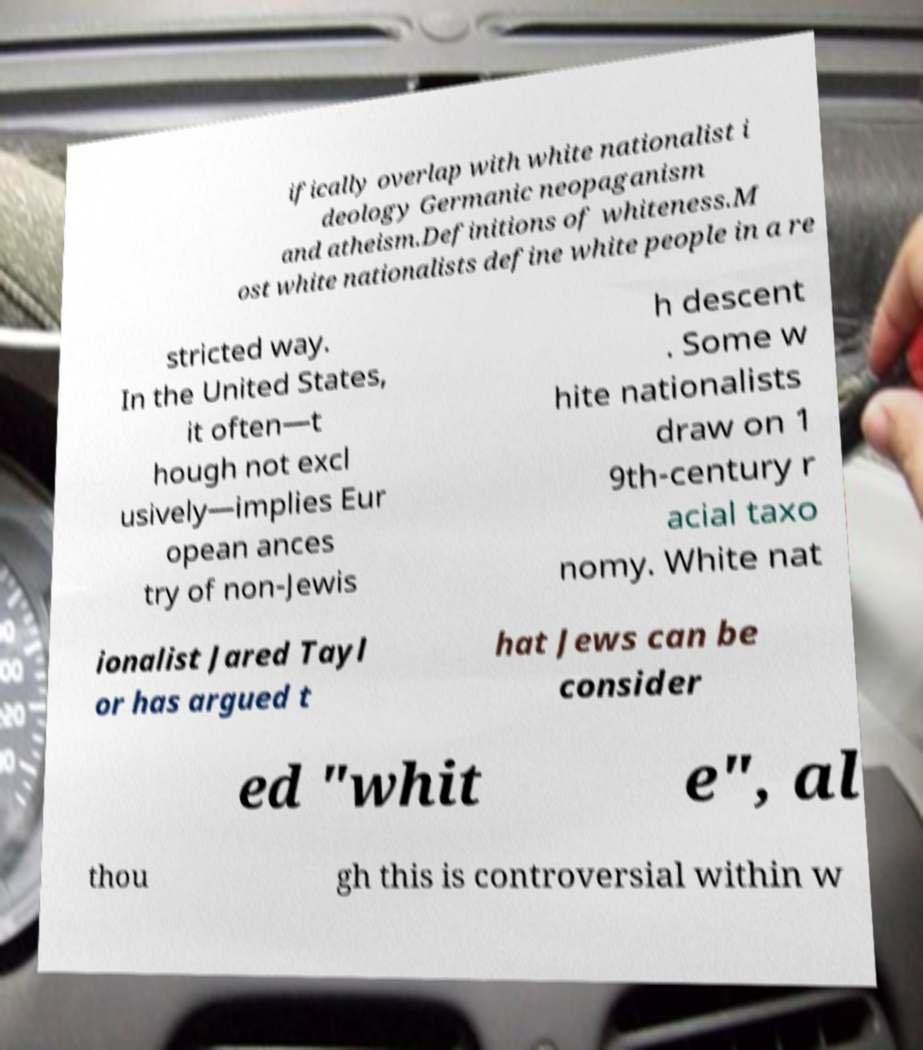What messages or text are displayed in this image? I need them in a readable, typed format. ifically overlap with white nationalist i deology Germanic neopaganism and atheism.Definitions of whiteness.M ost white nationalists define white people in a re stricted way. In the United States, it often—t hough not excl usively—implies Eur opean ances try of non-Jewis h descent . Some w hite nationalists draw on 1 9th-century r acial taxo nomy. White nat ionalist Jared Tayl or has argued t hat Jews can be consider ed "whit e", al thou gh this is controversial within w 